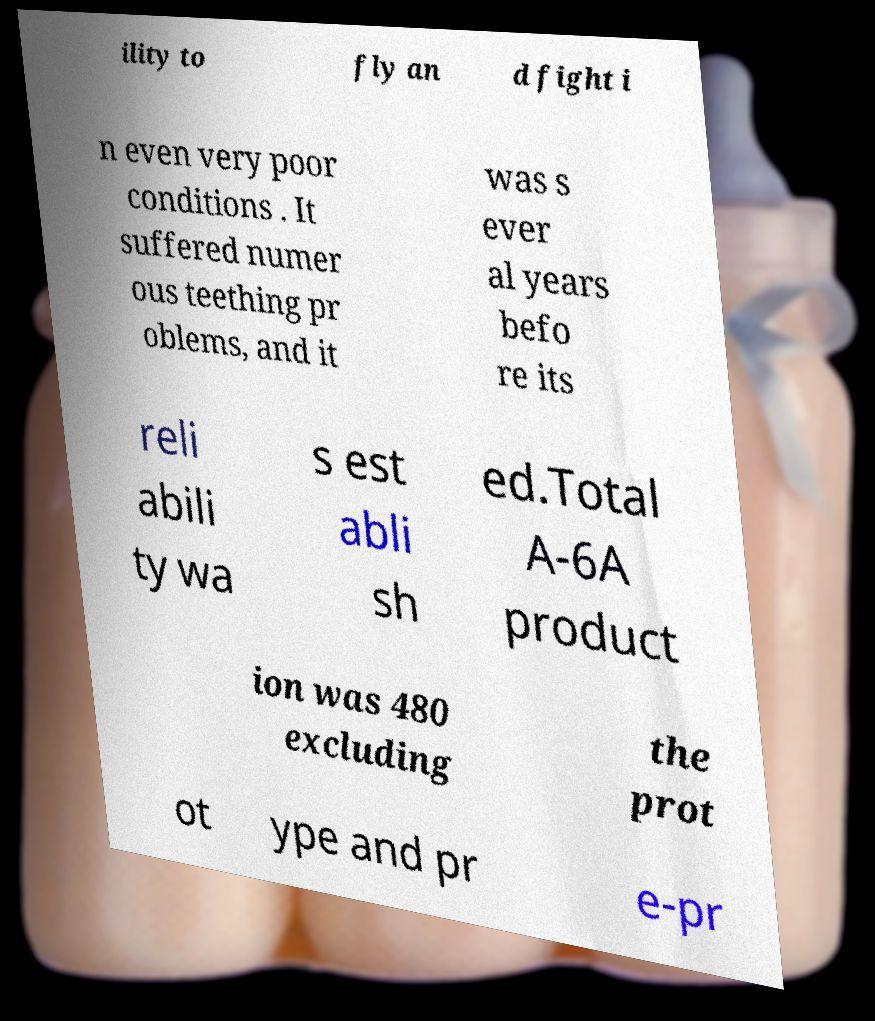Can you read and provide the text displayed in the image?This photo seems to have some interesting text. Can you extract and type it out for me? ility to fly an d fight i n even very poor conditions . It suffered numer ous teething pr oblems, and it was s ever al years befo re its reli abili ty wa s est abli sh ed.Total A-6A product ion was 480 excluding the prot ot ype and pr e-pr 